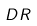Convert formula to latex. <formula><loc_0><loc_0><loc_500><loc_500>D R</formula> 